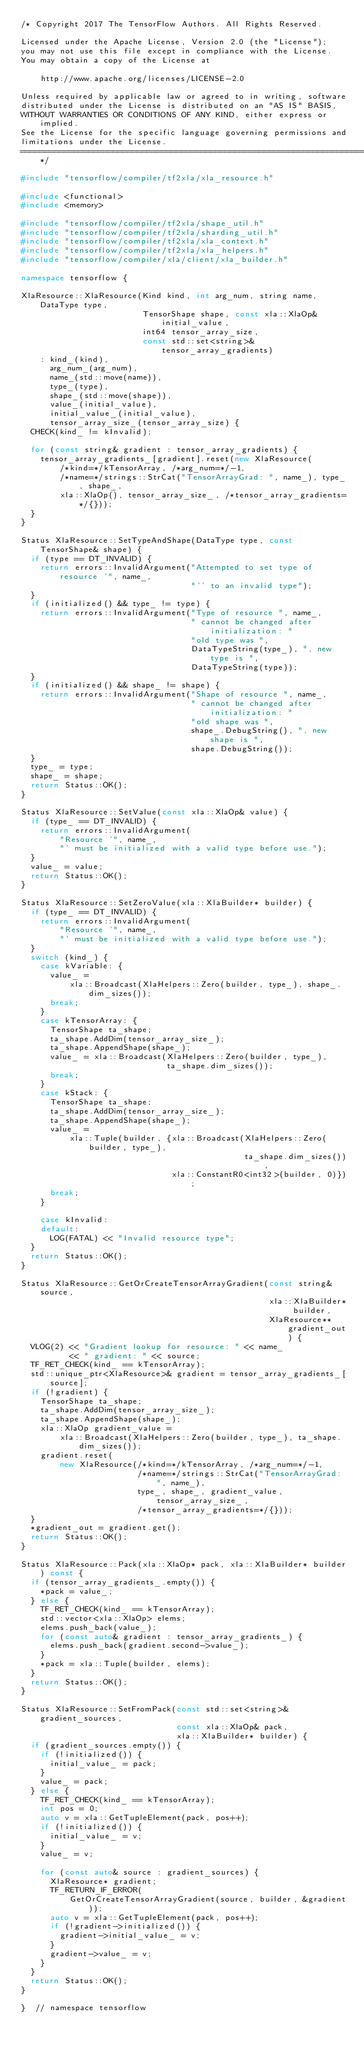<code> <loc_0><loc_0><loc_500><loc_500><_C++_>/* Copyright 2017 The TensorFlow Authors. All Rights Reserved.

Licensed under the Apache License, Version 2.0 (the "License");
you may not use this file except in compliance with the License.
You may obtain a copy of the License at

    http://www.apache.org/licenses/LICENSE-2.0

Unless required by applicable law or agreed to in writing, software
distributed under the License is distributed on an "AS IS" BASIS,
WITHOUT WARRANTIES OR CONDITIONS OF ANY KIND, either express or implied.
See the License for the specific language governing permissions and
limitations under the License.
==============================================================================*/

#include "tensorflow/compiler/tf2xla/xla_resource.h"

#include <functional>
#include <memory>

#include "tensorflow/compiler/tf2xla/shape_util.h"
#include "tensorflow/compiler/tf2xla/sharding_util.h"
#include "tensorflow/compiler/tf2xla/xla_context.h"
#include "tensorflow/compiler/tf2xla/xla_helpers.h"
#include "tensorflow/compiler/xla/client/xla_builder.h"

namespace tensorflow {

XlaResource::XlaResource(Kind kind, int arg_num, string name, DataType type,
                         TensorShape shape, const xla::XlaOp& initial_value,
                         int64 tensor_array_size,
                         const std::set<string>& tensor_array_gradients)
    : kind_(kind),
      arg_num_(arg_num),
      name_(std::move(name)),
      type_(type),
      shape_(std::move(shape)),
      value_(initial_value),
      initial_value_(initial_value),
      tensor_array_size_(tensor_array_size) {
  CHECK(kind_ != kInvalid);

  for (const string& gradient : tensor_array_gradients) {
    tensor_array_gradients_[gradient].reset(new XlaResource(
        /*kind=*/kTensorArray, /*arg_num=*/-1,
        /*name=*/strings::StrCat("TensorArrayGrad: ", name_), type_, shape_,
        xla::XlaOp(), tensor_array_size_, /*tensor_array_gradients=*/{}));
  }
}

Status XlaResource::SetTypeAndShape(DataType type, const TensorShape& shape) {
  if (type == DT_INVALID) {
    return errors::InvalidArgument("Attempted to set type of resource '", name_,
                                   "'' to an invalid type");
  }
  if (initialized() && type_ != type) {
    return errors::InvalidArgument("Type of resource ", name_,
                                   " cannot be changed after initialization: "
                                   "old type was ",
                                   DataTypeString(type_), ", new type is ",
                                   DataTypeString(type));
  }
  if (initialized() && shape_ != shape) {
    return errors::InvalidArgument("Shape of resource ", name_,
                                   " cannot be changed after initialization: "
                                   "old shape was ",
                                   shape_.DebugString(), ", new shape is ",
                                   shape.DebugString());
  }
  type_ = type;
  shape_ = shape;
  return Status::OK();
}

Status XlaResource::SetValue(const xla::XlaOp& value) {
  if (type_ == DT_INVALID) {
    return errors::InvalidArgument(
        "Resource '", name_,
        "' must be initialized with a valid type before use.");
  }
  value_ = value;
  return Status::OK();
}

Status XlaResource::SetZeroValue(xla::XlaBuilder* builder) {
  if (type_ == DT_INVALID) {
    return errors::InvalidArgument(
        "Resource '", name_,
        "' must be initialized with a valid type before use.");
  }
  switch (kind_) {
    case kVariable: {
      value_ =
          xla::Broadcast(XlaHelpers::Zero(builder, type_), shape_.dim_sizes());
      break;
    }
    case kTensorArray: {
      TensorShape ta_shape;
      ta_shape.AddDim(tensor_array_size_);
      ta_shape.AppendShape(shape_);
      value_ = xla::Broadcast(XlaHelpers::Zero(builder, type_),
                              ta_shape.dim_sizes());
      break;
    }
    case kStack: {
      TensorShape ta_shape;
      ta_shape.AddDim(tensor_array_size_);
      ta_shape.AppendShape(shape_);
      value_ =
          xla::Tuple(builder, {xla::Broadcast(XlaHelpers::Zero(builder, type_),
                                              ta_shape.dim_sizes()),
                               xla::ConstantR0<int32>(builder, 0)});
      break;
    }

    case kInvalid:
    default:
      LOG(FATAL) << "Invalid resource type";
  }
  return Status::OK();
}

Status XlaResource::GetOrCreateTensorArrayGradient(const string& source,
                                                   xla::XlaBuilder* builder,
                                                   XlaResource** gradient_out) {
  VLOG(2) << "Gradient lookup for resource: " << name_
          << " gradient: " << source;
  TF_RET_CHECK(kind_ == kTensorArray);
  std::unique_ptr<XlaResource>& gradient = tensor_array_gradients_[source];
  if (!gradient) {
    TensorShape ta_shape;
    ta_shape.AddDim(tensor_array_size_);
    ta_shape.AppendShape(shape_);
    xla::XlaOp gradient_value =
        xla::Broadcast(XlaHelpers::Zero(builder, type_), ta_shape.dim_sizes());
    gradient.reset(
        new XlaResource(/*kind=*/kTensorArray, /*arg_num=*/-1,
                        /*name=*/strings::StrCat("TensorArrayGrad: ", name_),
                        type_, shape_, gradient_value, tensor_array_size_,
                        /*tensor_array_gradients=*/{}));
  }
  *gradient_out = gradient.get();
  return Status::OK();
}

Status XlaResource::Pack(xla::XlaOp* pack, xla::XlaBuilder* builder) const {
  if (tensor_array_gradients_.empty()) {
    *pack = value_;
  } else {
    TF_RET_CHECK(kind_ == kTensorArray);
    std::vector<xla::XlaOp> elems;
    elems.push_back(value_);
    for (const auto& gradient : tensor_array_gradients_) {
      elems.push_back(gradient.second->value_);
    }
    *pack = xla::Tuple(builder, elems);
  }
  return Status::OK();
}

Status XlaResource::SetFromPack(const std::set<string>& gradient_sources,
                                const xla::XlaOp& pack,
                                xla::XlaBuilder* builder) {
  if (gradient_sources.empty()) {
    if (!initialized()) {
      initial_value_ = pack;
    }
    value_ = pack;
  } else {
    TF_RET_CHECK(kind_ == kTensorArray);
    int pos = 0;
    auto v = xla::GetTupleElement(pack, pos++);
    if (!initialized()) {
      initial_value_ = v;
    }
    value_ = v;

    for (const auto& source : gradient_sources) {
      XlaResource* gradient;
      TF_RETURN_IF_ERROR(
          GetOrCreateTensorArrayGradient(source, builder, &gradient));
      auto v = xla::GetTupleElement(pack, pos++);
      if (!gradient->initialized()) {
        gradient->initial_value_ = v;
      }
      gradient->value_ = v;
    }
  }
  return Status::OK();
}

}  // namespace tensorflow
</code> 